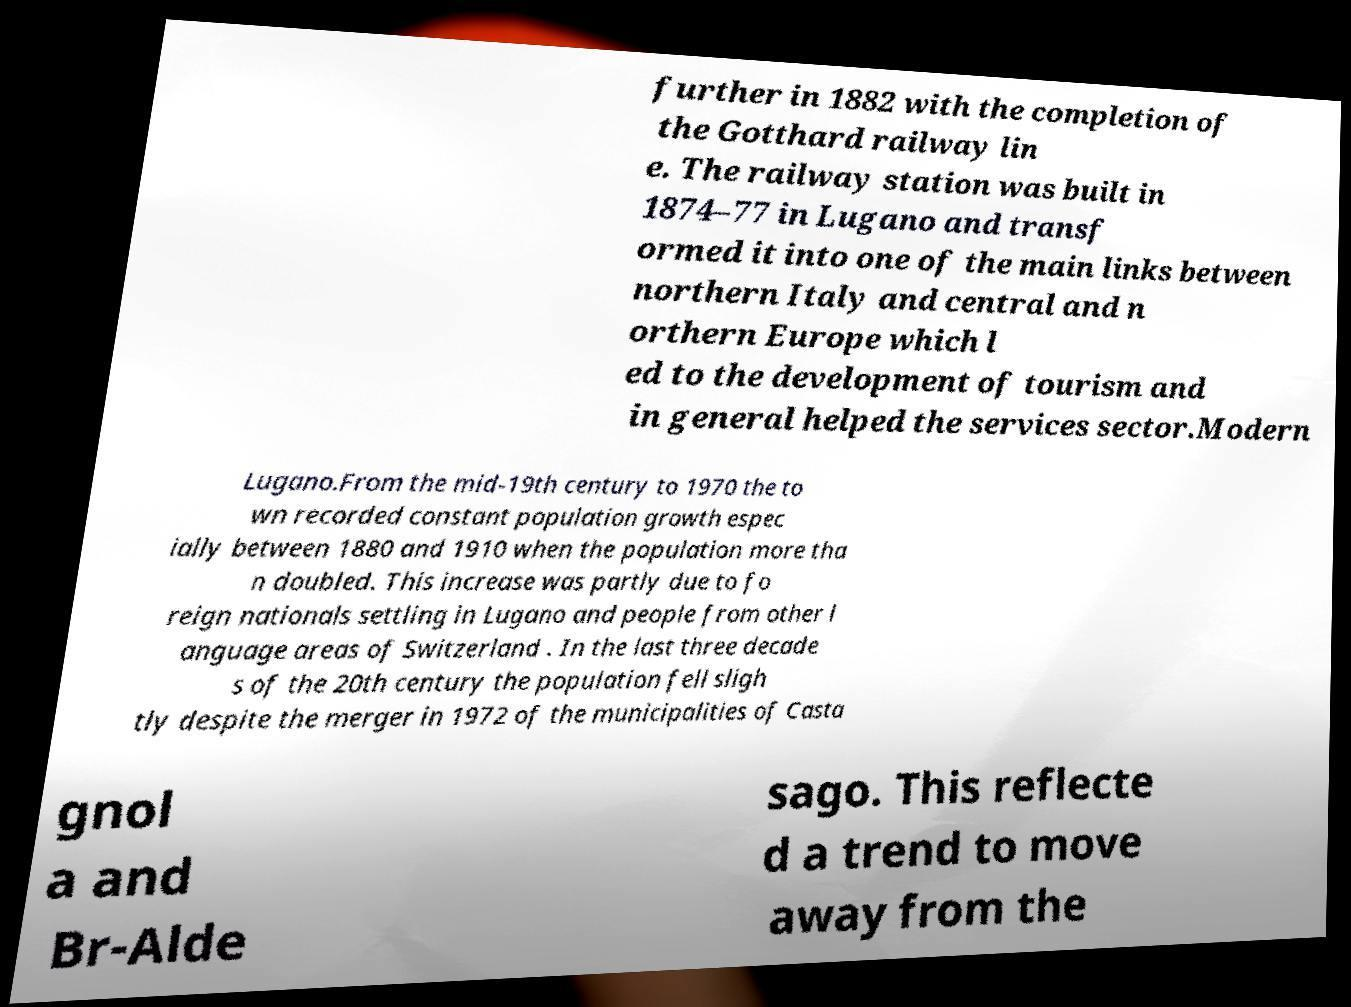I need the written content from this picture converted into text. Can you do that? further in 1882 with the completion of the Gotthard railway lin e. The railway station was built in 1874–77 in Lugano and transf ormed it into one of the main links between northern Italy and central and n orthern Europe which l ed to the development of tourism and in general helped the services sector.Modern Lugano.From the mid-19th century to 1970 the to wn recorded constant population growth espec ially between 1880 and 1910 when the population more tha n doubled. This increase was partly due to fo reign nationals settling in Lugano and people from other l anguage areas of Switzerland . In the last three decade s of the 20th century the population fell sligh tly despite the merger in 1972 of the municipalities of Casta gnol a and Br-Alde sago. This reflecte d a trend to move away from the 